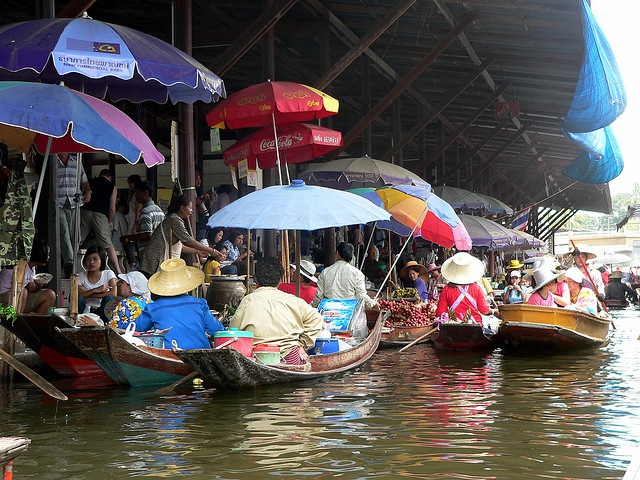Describe the objects in this image and their specific colors. I can see umbrella in black, navy, purple, and blue tones, people in black, gray, lightgray, and darkgray tones, umbrella in black, blue, violet, and darkgray tones, boat in black, gray, lightgray, and lightpink tones, and umbrella in black and lightblue tones in this image. 